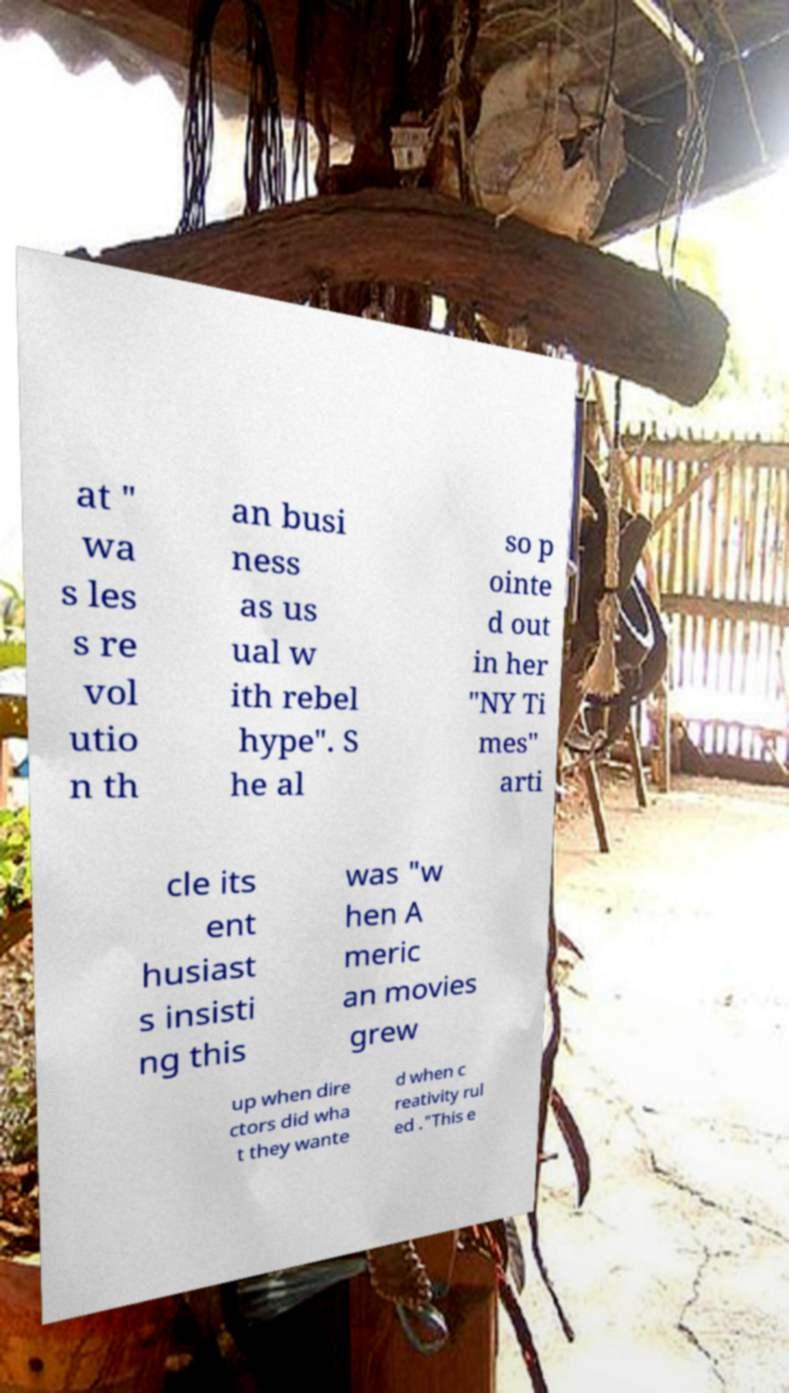Please identify and transcribe the text found in this image. at " wa s les s re vol utio n th an busi ness as us ual w ith rebel hype". S he al so p ointe d out in her "NY Ti mes" arti cle its ent husiast s insisti ng this was "w hen A meric an movies grew up when dire ctors did wha t they wante d when c reativity rul ed ."This e 